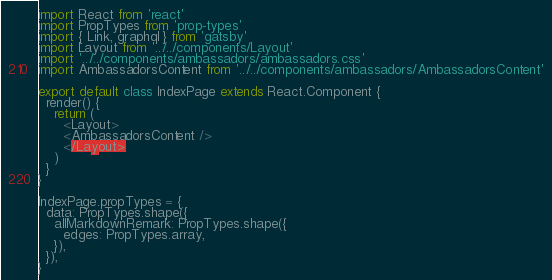Convert code to text. <code><loc_0><loc_0><loc_500><loc_500><_JavaScript_>import React from 'react'
import PropTypes from 'prop-types'
import { Link, graphql } from 'gatsby'
import Layout from '../../components/Layout'
import '../../components/ambassadors/ambassadors.css'
import AmbassadorsContent from '../../components/ambassadors/AmbassadorsContent'

export default class IndexPage extends React.Component {
  render() {
    return (
      <Layout>
      <AmbassadorsContent />
      </Layout>
    )
  }
}

IndexPage.propTypes = {
  data: PropTypes.shape({
    allMarkdownRemark: PropTypes.shape({
      edges: PropTypes.array,
    }),
  }),
}
</code> 